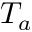<formula> <loc_0><loc_0><loc_500><loc_500>T _ { a }</formula> 